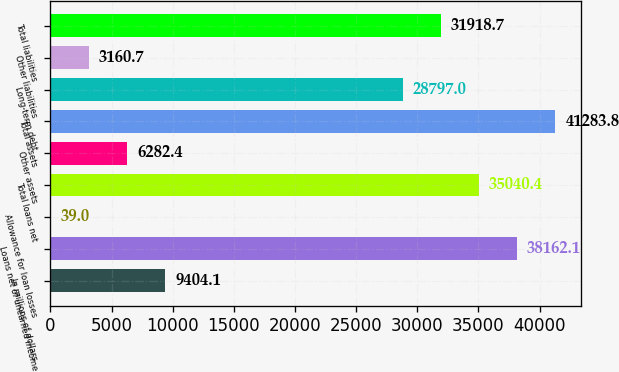Convert chart. <chart><loc_0><loc_0><loc_500><loc_500><bar_chart><fcel>In millions of dollars<fcel>Loans net of unearned income<fcel>Allowance for loan losses<fcel>Total loans net<fcel>Other assets<fcel>Total assets<fcel>Long-term debt<fcel>Other liabilities<fcel>Total liabilities<nl><fcel>9404.1<fcel>38162.1<fcel>39<fcel>35040.4<fcel>6282.4<fcel>41283.8<fcel>28797<fcel>3160.7<fcel>31918.7<nl></chart> 